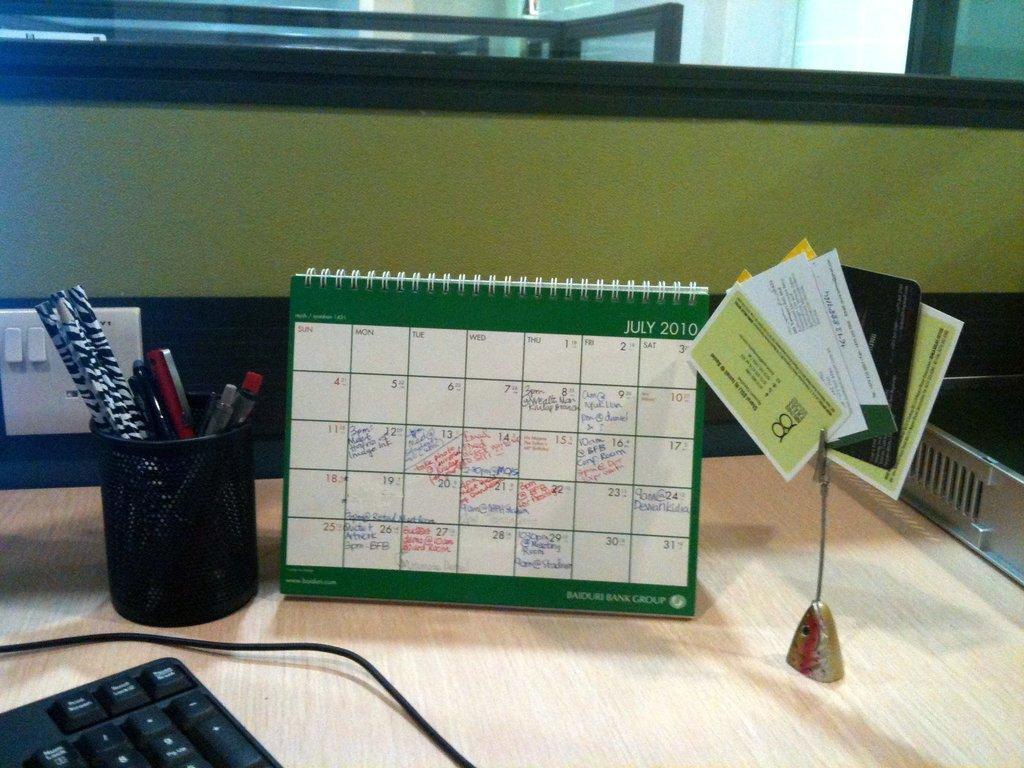Could you give a brief overview of what you see in this image? This picture is taken inside the room. In this image, on the right side of the table, we can see one edge of a tray. On the right side, we can see a pointer with some cards attached to it. In the middle of the image, we can see a calendar. In the left corner, we can see a keyboard and electrical wires. On the left side, we can see a glass with some pens. In the background, we can see a switch board, glass window. 